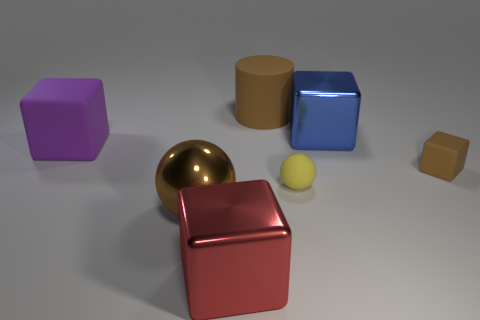How many large brown things are the same material as the yellow sphere?
Make the answer very short. 1. There is a yellow thing; is its size the same as the metal cube that is behind the small brown thing?
Your response must be concise. No. There is a rubber object that is behind the brown rubber cube and in front of the big blue metallic block; what is its color?
Offer a very short reply. Purple. There is a object that is on the left side of the metal ball; are there any large purple cubes behind it?
Your answer should be compact. No. Are there the same number of large red blocks to the left of the large purple matte cube and purple objects?
Keep it short and to the point. No. How many rubber objects are right of the brown thing that is behind the rubber block that is left of the blue metallic object?
Provide a succinct answer. 2. Are there any other matte cylinders that have the same size as the matte cylinder?
Your answer should be compact. No. Is the number of red metal cubes that are in front of the big brown sphere less than the number of large matte blocks?
Your response must be concise. No. What is the material of the big brown thing behind the shiny cube on the right side of the metal block that is in front of the small brown thing?
Your response must be concise. Rubber. Is the number of small brown things in front of the yellow ball greater than the number of brown shiny objects to the right of the large purple matte object?
Your answer should be compact. No. 